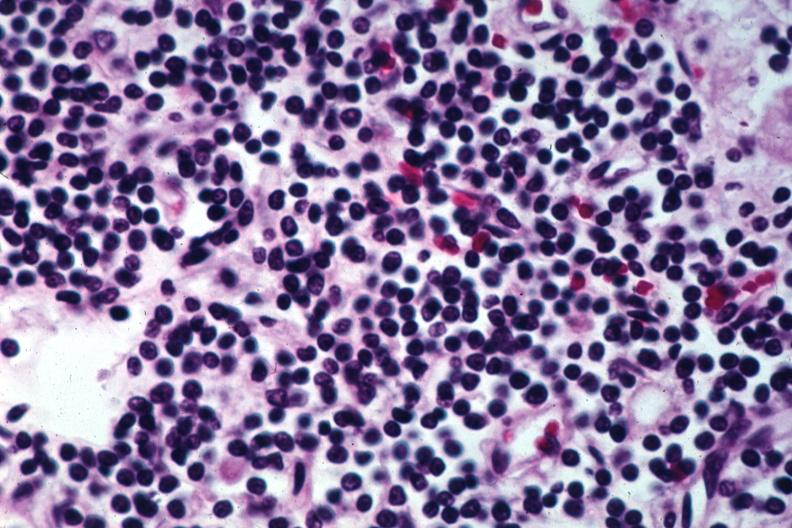s chronic lymphocytic leukemia present?
Answer the question using a single word or phrase. Yes 